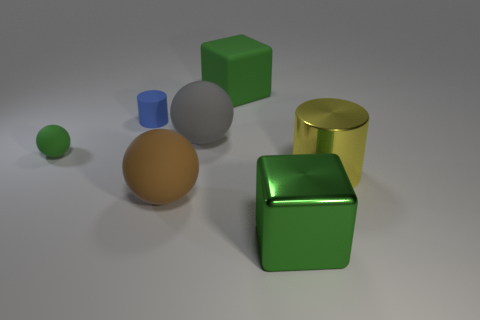What artistic principles could be gleaned from the arrangement of these objects? This arrangement demonstrates principles such as balance, with the objects spread throughout the frame; contrast, via the use of different colors and materials; and depth, with the placement of objects both in the foreground and background. Additionally, there is an exploration of geometric shapes and how they interact with lighting. 